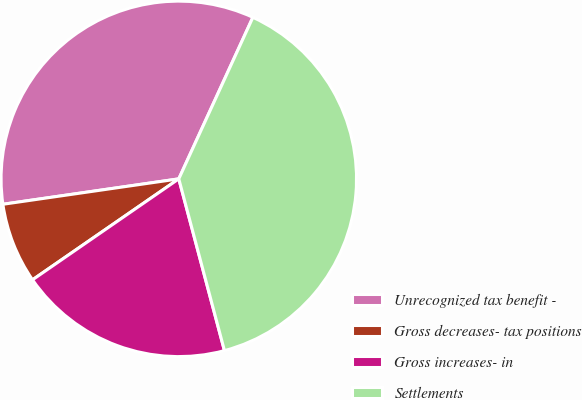Convert chart. <chart><loc_0><loc_0><loc_500><loc_500><pie_chart><fcel>Unrecognized tax benefit -<fcel>Gross decreases- tax positions<fcel>Gross increases- in<fcel>Settlements<nl><fcel>34.13%<fcel>7.33%<fcel>19.52%<fcel>39.02%<nl></chart> 